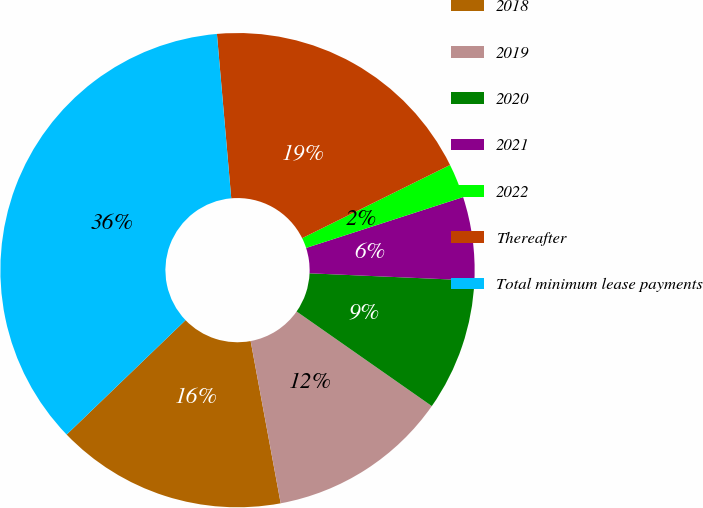Convert chart. <chart><loc_0><loc_0><loc_500><loc_500><pie_chart><fcel>2018<fcel>2019<fcel>2020<fcel>2021<fcel>2022<fcel>Thereafter<fcel>Total minimum lease payments<nl><fcel>15.72%<fcel>12.37%<fcel>9.02%<fcel>5.68%<fcel>2.33%<fcel>19.07%<fcel>35.81%<nl></chart> 